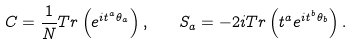Convert formula to latex. <formula><loc_0><loc_0><loc_500><loc_500>C = \frac { 1 } { N } { T r } \left ( e ^ { i { t } ^ { a } { \theta } _ { a } } \right ) , \quad S _ { a } = - 2 i { T r } \left ( t ^ { a } e ^ { i { t } ^ { b } { \theta } _ { b } } \right ) .</formula> 